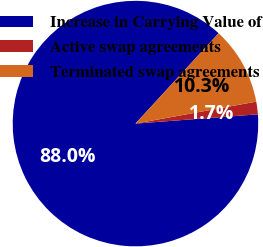<chart> <loc_0><loc_0><loc_500><loc_500><pie_chart><fcel>Increase in Carrying Value of<fcel>Active swap agreements<fcel>Terminated swap agreements<nl><fcel>88.03%<fcel>1.66%<fcel>10.3%<nl></chart> 